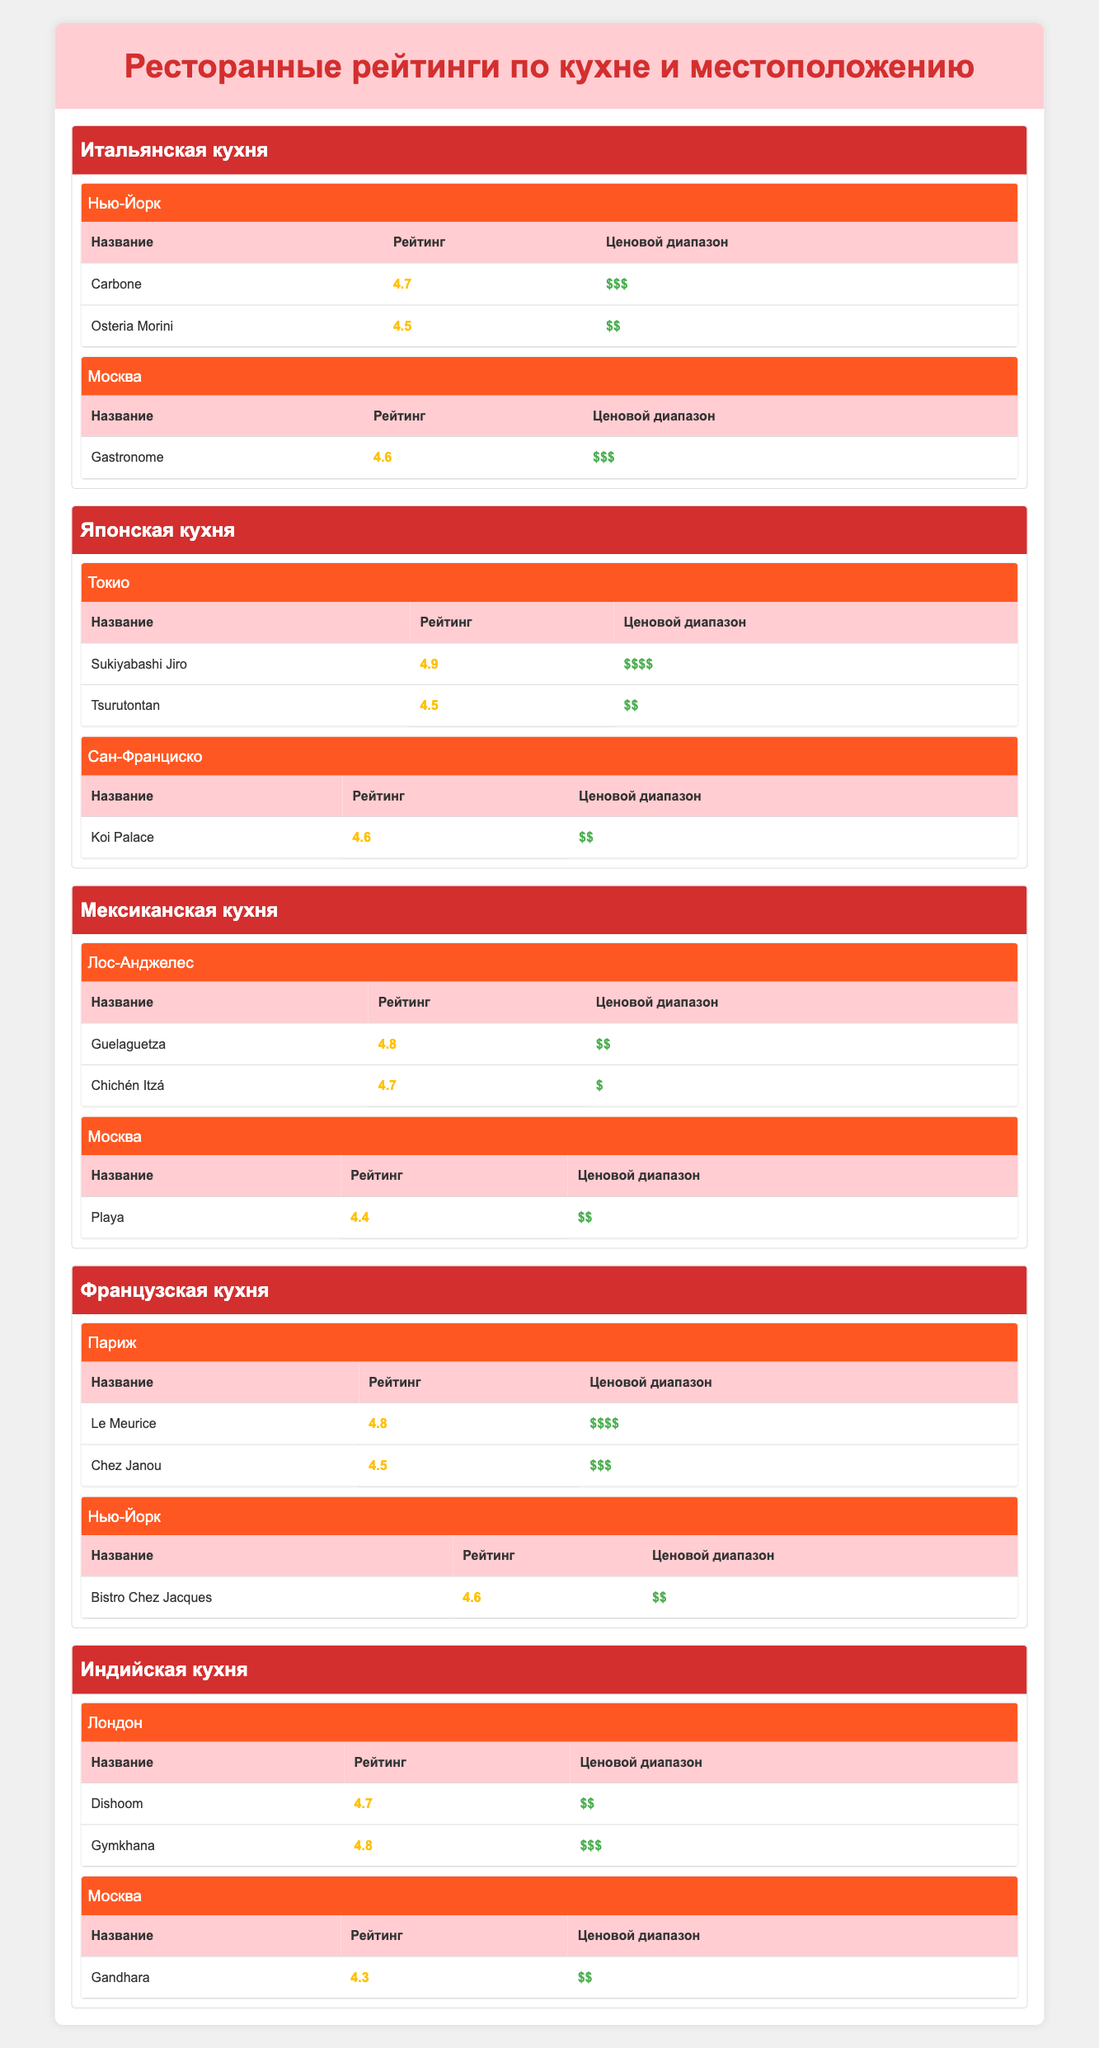What is the highest rated restaurant in Tokyo? The highest rated restaurant in Tokyo is Sukiyabashi Jiro with a rating of 4.9. This is found in the Japanese cuisine section under the location of Tokyo.
Answer: Sukiyabashi Jiro Which city has the lowest-rated Mexican restaurant? The Mexican restaurant with the lowest rating is Playa located in Moscow, with a rating of 4.4. This can be determined by comparing the ratings of Mexican restaurants in Los Angeles and Moscow.
Answer: Moscow What is the average rating of Indian restaurants in London? The Indian restaurants listed in London are Dishoom with a rating of 4.7 and Gymkhana with a rating of 4.8. To find the average rating, we sum the ratings (4.7 + 4.8) and then divide by the number of restaurants (2). So, (4.7 + 4.8) / 2 = 4.75.
Answer: 4.75 Is there a French restaurant with a rating above 4.5 in New York? Yes, Bistro Chez Jacques is a French restaurant in New York with a rating of 4.6, which is above 4.5. This can be confirmed by checking the French cuisine section for the New York entry.
Answer: Yes How many Italian restaurants are there in Moscow, and what is their average rating? There is only one Italian restaurant in Moscow, which is Gastronome with a rating of 4.6. Since there's only one restaurant, the average rating is simply 4.6.
Answer: 4.6 